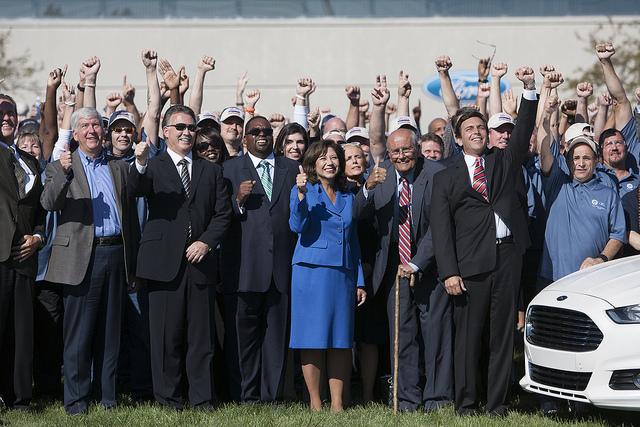Where do most of the people have one of their arms?
Keep it brief. In air. What color is the front of this vehicle?
Concise answer only. White. What is the woman in front wearing?
Keep it brief. Suit. 